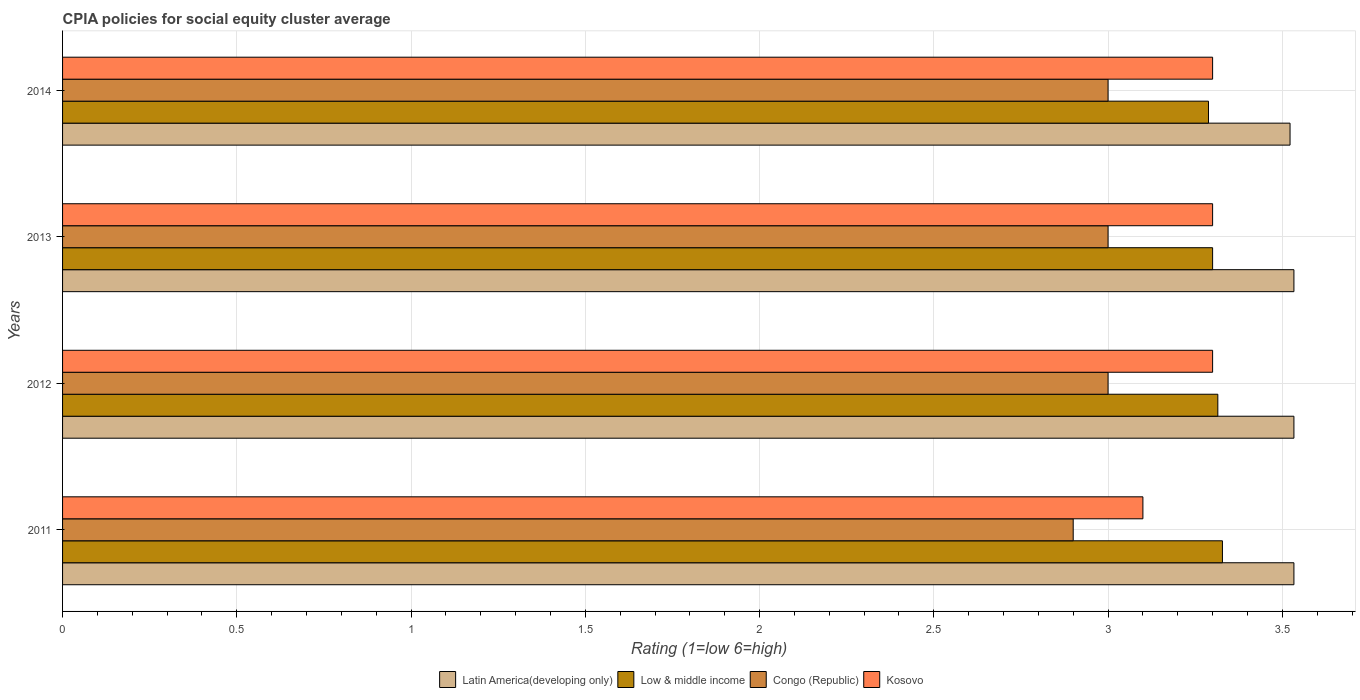How many different coloured bars are there?
Offer a terse response. 4. How many groups of bars are there?
Offer a terse response. 4. Are the number of bars on each tick of the Y-axis equal?
Your answer should be very brief. Yes. How many bars are there on the 3rd tick from the top?
Your answer should be compact. 4. How many bars are there on the 4th tick from the bottom?
Make the answer very short. 4. In how many cases, is the number of bars for a given year not equal to the number of legend labels?
Keep it short and to the point. 0. What is the CPIA rating in Latin America(developing only) in 2014?
Your answer should be very brief. 3.52. Across all years, what is the maximum CPIA rating in Congo (Republic)?
Give a very brief answer. 3. Across all years, what is the minimum CPIA rating in Latin America(developing only)?
Provide a succinct answer. 3.52. In which year was the CPIA rating in Kosovo maximum?
Your answer should be compact. 2012. What is the difference between the CPIA rating in Low & middle income in 2011 and that in 2014?
Make the answer very short. 0.04. What is the difference between the CPIA rating in Kosovo in 2013 and the CPIA rating in Low & middle income in 2012?
Provide a succinct answer. -0.02. What is the average CPIA rating in Congo (Republic) per year?
Your answer should be very brief. 2.98. In the year 2011, what is the difference between the CPIA rating in Congo (Republic) and CPIA rating in Low & middle income?
Keep it short and to the point. -0.43. In how many years, is the CPIA rating in Low & middle income greater than 1.6 ?
Make the answer very short. 4. What is the ratio of the CPIA rating in Low & middle income in 2011 to that in 2013?
Offer a terse response. 1.01. What is the difference between the highest and the second highest CPIA rating in Low & middle income?
Keep it short and to the point. 0.01. What is the difference between the highest and the lowest CPIA rating in Low & middle income?
Your answer should be compact. 0.04. What does the 4th bar from the top in 2013 represents?
Your response must be concise. Latin America(developing only). What does the 3rd bar from the bottom in 2014 represents?
Offer a very short reply. Congo (Republic). Is it the case that in every year, the sum of the CPIA rating in Latin America(developing only) and CPIA rating in Kosovo is greater than the CPIA rating in Low & middle income?
Offer a very short reply. Yes. Does the graph contain any zero values?
Ensure brevity in your answer.  No. What is the title of the graph?
Ensure brevity in your answer.  CPIA policies for social equity cluster average. Does "Euro area" appear as one of the legend labels in the graph?
Offer a very short reply. No. What is the label or title of the X-axis?
Offer a terse response. Rating (1=low 6=high). What is the label or title of the Y-axis?
Provide a short and direct response. Years. What is the Rating (1=low 6=high) of Latin America(developing only) in 2011?
Offer a very short reply. 3.53. What is the Rating (1=low 6=high) in Low & middle income in 2011?
Your answer should be compact. 3.33. What is the Rating (1=low 6=high) in Congo (Republic) in 2011?
Offer a very short reply. 2.9. What is the Rating (1=low 6=high) of Kosovo in 2011?
Your answer should be compact. 3.1. What is the Rating (1=low 6=high) of Latin America(developing only) in 2012?
Give a very brief answer. 3.53. What is the Rating (1=low 6=high) of Low & middle income in 2012?
Give a very brief answer. 3.31. What is the Rating (1=low 6=high) of Kosovo in 2012?
Keep it short and to the point. 3.3. What is the Rating (1=low 6=high) in Latin America(developing only) in 2013?
Offer a very short reply. 3.53. What is the Rating (1=low 6=high) of Low & middle income in 2013?
Make the answer very short. 3.3. What is the Rating (1=low 6=high) in Congo (Republic) in 2013?
Provide a short and direct response. 3. What is the Rating (1=low 6=high) of Latin America(developing only) in 2014?
Provide a succinct answer. 3.52. What is the Rating (1=low 6=high) in Low & middle income in 2014?
Your answer should be compact. 3.29. What is the Rating (1=low 6=high) of Kosovo in 2014?
Ensure brevity in your answer.  3.3. Across all years, what is the maximum Rating (1=low 6=high) in Latin America(developing only)?
Ensure brevity in your answer.  3.53. Across all years, what is the maximum Rating (1=low 6=high) of Low & middle income?
Provide a short and direct response. 3.33. Across all years, what is the maximum Rating (1=low 6=high) in Kosovo?
Your answer should be compact. 3.3. Across all years, what is the minimum Rating (1=low 6=high) in Latin America(developing only)?
Keep it short and to the point. 3.52. Across all years, what is the minimum Rating (1=low 6=high) in Low & middle income?
Offer a very short reply. 3.29. Across all years, what is the minimum Rating (1=low 6=high) of Kosovo?
Your response must be concise. 3.1. What is the total Rating (1=low 6=high) in Latin America(developing only) in the graph?
Ensure brevity in your answer.  14.12. What is the total Rating (1=low 6=high) in Low & middle income in the graph?
Offer a very short reply. 13.23. What is the total Rating (1=low 6=high) of Congo (Republic) in the graph?
Ensure brevity in your answer.  11.9. What is the difference between the Rating (1=low 6=high) in Low & middle income in 2011 and that in 2012?
Your answer should be very brief. 0.01. What is the difference between the Rating (1=low 6=high) in Congo (Republic) in 2011 and that in 2012?
Your answer should be very brief. -0.1. What is the difference between the Rating (1=low 6=high) in Low & middle income in 2011 and that in 2013?
Offer a terse response. 0.03. What is the difference between the Rating (1=low 6=high) of Kosovo in 2011 and that in 2013?
Provide a succinct answer. -0.2. What is the difference between the Rating (1=low 6=high) in Latin America(developing only) in 2011 and that in 2014?
Offer a very short reply. 0.01. What is the difference between the Rating (1=low 6=high) in Kosovo in 2011 and that in 2014?
Your response must be concise. -0.2. What is the difference between the Rating (1=low 6=high) of Low & middle income in 2012 and that in 2013?
Give a very brief answer. 0.01. What is the difference between the Rating (1=low 6=high) of Kosovo in 2012 and that in 2013?
Give a very brief answer. 0. What is the difference between the Rating (1=low 6=high) in Latin America(developing only) in 2012 and that in 2014?
Your answer should be very brief. 0.01. What is the difference between the Rating (1=low 6=high) in Low & middle income in 2012 and that in 2014?
Offer a terse response. 0.03. What is the difference between the Rating (1=low 6=high) of Latin America(developing only) in 2013 and that in 2014?
Give a very brief answer. 0.01. What is the difference between the Rating (1=low 6=high) in Low & middle income in 2013 and that in 2014?
Keep it short and to the point. 0.01. What is the difference between the Rating (1=low 6=high) of Congo (Republic) in 2013 and that in 2014?
Provide a short and direct response. 0. What is the difference between the Rating (1=low 6=high) of Kosovo in 2013 and that in 2014?
Keep it short and to the point. 0. What is the difference between the Rating (1=low 6=high) of Latin America(developing only) in 2011 and the Rating (1=low 6=high) of Low & middle income in 2012?
Provide a succinct answer. 0.22. What is the difference between the Rating (1=low 6=high) of Latin America(developing only) in 2011 and the Rating (1=low 6=high) of Congo (Republic) in 2012?
Your answer should be very brief. 0.53. What is the difference between the Rating (1=low 6=high) of Latin America(developing only) in 2011 and the Rating (1=low 6=high) of Kosovo in 2012?
Give a very brief answer. 0.23. What is the difference between the Rating (1=low 6=high) in Low & middle income in 2011 and the Rating (1=low 6=high) in Congo (Republic) in 2012?
Ensure brevity in your answer.  0.33. What is the difference between the Rating (1=low 6=high) in Low & middle income in 2011 and the Rating (1=low 6=high) in Kosovo in 2012?
Provide a succinct answer. 0.03. What is the difference between the Rating (1=low 6=high) in Congo (Republic) in 2011 and the Rating (1=low 6=high) in Kosovo in 2012?
Keep it short and to the point. -0.4. What is the difference between the Rating (1=low 6=high) in Latin America(developing only) in 2011 and the Rating (1=low 6=high) in Low & middle income in 2013?
Make the answer very short. 0.23. What is the difference between the Rating (1=low 6=high) of Latin America(developing only) in 2011 and the Rating (1=low 6=high) of Congo (Republic) in 2013?
Make the answer very short. 0.53. What is the difference between the Rating (1=low 6=high) in Latin America(developing only) in 2011 and the Rating (1=low 6=high) in Kosovo in 2013?
Keep it short and to the point. 0.23. What is the difference between the Rating (1=low 6=high) in Low & middle income in 2011 and the Rating (1=low 6=high) in Congo (Republic) in 2013?
Offer a terse response. 0.33. What is the difference between the Rating (1=low 6=high) of Low & middle income in 2011 and the Rating (1=low 6=high) of Kosovo in 2013?
Offer a terse response. 0.03. What is the difference between the Rating (1=low 6=high) of Latin America(developing only) in 2011 and the Rating (1=low 6=high) of Low & middle income in 2014?
Offer a terse response. 0.25. What is the difference between the Rating (1=low 6=high) of Latin America(developing only) in 2011 and the Rating (1=low 6=high) of Congo (Republic) in 2014?
Offer a very short reply. 0.53. What is the difference between the Rating (1=low 6=high) in Latin America(developing only) in 2011 and the Rating (1=low 6=high) in Kosovo in 2014?
Your answer should be very brief. 0.23. What is the difference between the Rating (1=low 6=high) in Low & middle income in 2011 and the Rating (1=low 6=high) in Congo (Republic) in 2014?
Make the answer very short. 0.33. What is the difference between the Rating (1=low 6=high) in Low & middle income in 2011 and the Rating (1=low 6=high) in Kosovo in 2014?
Ensure brevity in your answer.  0.03. What is the difference between the Rating (1=low 6=high) in Latin America(developing only) in 2012 and the Rating (1=low 6=high) in Low & middle income in 2013?
Your answer should be compact. 0.23. What is the difference between the Rating (1=low 6=high) of Latin America(developing only) in 2012 and the Rating (1=low 6=high) of Congo (Republic) in 2013?
Give a very brief answer. 0.53. What is the difference between the Rating (1=low 6=high) in Latin America(developing only) in 2012 and the Rating (1=low 6=high) in Kosovo in 2013?
Offer a very short reply. 0.23. What is the difference between the Rating (1=low 6=high) in Low & middle income in 2012 and the Rating (1=low 6=high) in Congo (Republic) in 2013?
Your answer should be compact. 0.32. What is the difference between the Rating (1=low 6=high) of Low & middle income in 2012 and the Rating (1=low 6=high) of Kosovo in 2013?
Provide a succinct answer. 0.01. What is the difference between the Rating (1=low 6=high) in Latin America(developing only) in 2012 and the Rating (1=low 6=high) in Low & middle income in 2014?
Offer a terse response. 0.25. What is the difference between the Rating (1=low 6=high) in Latin America(developing only) in 2012 and the Rating (1=low 6=high) in Congo (Republic) in 2014?
Give a very brief answer. 0.53. What is the difference between the Rating (1=low 6=high) in Latin America(developing only) in 2012 and the Rating (1=low 6=high) in Kosovo in 2014?
Make the answer very short. 0.23. What is the difference between the Rating (1=low 6=high) of Low & middle income in 2012 and the Rating (1=low 6=high) of Congo (Republic) in 2014?
Ensure brevity in your answer.  0.32. What is the difference between the Rating (1=low 6=high) in Low & middle income in 2012 and the Rating (1=low 6=high) in Kosovo in 2014?
Your response must be concise. 0.01. What is the difference between the Rating (1=low 6=high) in Congo (Republic) in 2012 and the Rating (1=low 6=high) in Kosovo in 2014?
Provide a short and direct response. -0.3. What is the difference between the Rating (1=low 6=high) in Latin America(developing only) in 2013 and the Rating (1=low 6=high) in Low & middle income in 2014?
Give a very brief answer. 0.25. What is the difference between the Rating (1=low 6=high) of Latin America(developing only) in 2013 and the Rating (1=low 6=high) of Congo (Republic) in 2014?
Provide a succinct answer. 0.53. What is the difference between the Rating (1=low 6=high) in Latin America(developing only) in 2013 and the Rating (1=low 6=high) in Kosovo in 2014?
Your answer should be compact. 0.23. What is the average Rating (1=low 6=high) of Latin America(developing only) per year?
Your response must be concise. 3.53. What is the average Rating (1=low 6=high) in Low & middle income per year?
Offer a very short reply. 3.31. What is the average Rating (1=low 6=high) in Congo (Republic) per year?
Your response must be concise. 2.98. What is the average Rating (1=low 6=high) in Kosovo per year?
Offer a terse response. 3.25. In the year 2011, what is the difference between the Rating (1=low 6=high) of Latin America(developing only) and Rating (1=low 6=high) of Low & middle income?
Make the answer very short. 0.21. In the year 2011, what is the difference between the Rating (1=low 6=high) of Latin America(developing only) and Rating (1=low 6=high) of Congo (Republic)?
Provide a short and direct response. 0.63. In the year 2011, what is the difference between the Rating (1=low 6=high) in Latin America(developing only) and Rating (1=low 6=high) in Kosovo?
Ensure brevity in your answer.  0.43. In the year 2011, what is the difference between the Rating (1=low 6=high) in Low & middle income and Rating (1=low 6=high) in Congo (Republic)?
Provide a succinct answer. 0.43. In the year 2011, what is the difference between the Rating (1=low 6=high) in Low & middle income and Rating (1=low 6=high) in Kosovo?
Keep it short and to the point. 0.23. In the year 2012, what is the difference between the Rating (1=low 6=high) of Latin America(developing only) and Rating (1=low 6=high) of Low & middle income?
Ensure brevity in your answer.  0.22. In the year 2012, what is the difference between the Rating (1=low 6=high) of Latin America(developing only) and Rating (1=low 6=high) of Congo (Republic)?
Provide a short and direct response. 0.53. In the year 2012, what is the difference between the Rating (1=low 6=high) of Latin America(developing only) and Rating (1=low 6=high) of Kosovo?
Your answer should be compact. 0.23. In the year 2012, what is the difference between the Rating (1=low 6=high) in Low & middle income and Rating (1=low 6=high) in Congo (Republic)?
Provide a short and direct response. 0.32. In the year 2012, what is the difference between the Rating (1=low 6=high) of Low & middle income and Rating (1=low 6=high) of Kosovo?
Your answer should be compact. 0.01. In the year 2012, what is the difference between the Rating (1=low 6=high) in Congo (Republic) and Rating (1=low 6=high) in Kosovo?
Keep it short and to the point. -0.3. In the year 2013, what is the difference between the Rating (1=low 6=high) of Latin America(developing only) and Rating (1=low 6=high) of Low & middle income?
Provide a succinct answer. 0.23. In the year 2013, what is the difference between the Rating (1=low 6=high) in Latin America(developing only) and Rating (1=low 6=high) in Congo (Republic)?
Offer a terse response. 0.53. In the year 2013, what is the difference between the Rating (1=low 6=high) in Latin America(developing only) and Rating (1=low 6=high) in Kosovo?
Offer a terse response. 0.23. In the year 2013, what is the difference between the Rating (1=low 6=high) of Low & middle income and Rating (1=low 6=high) of Congo (Republic)?
Provide a succinct answer. 0.3. In the year 2013, what is the difference between the Rating (1=low 6=high) of Low & middle income and Rating (1=low 6=high) of Kosovo?
Keep it short and to the point. 0. In the year 2014, what is the difference between the Rating (1=low 6=high) of Latin America(developing only) and Rating (1=low 6=high) of Low & middle income?
Your response must be concise. 0.23. In the year 2014, what is the difference between the Rating (1=low 6=high) in Latin America(developing only) and Rating (1=low 6=high) in Congo (Republic)?
Ensure brevity in your answer.  0.52. In the year 2014, what is the difference between the Rating (1=low 6=high) in Latin America(developing only) and Rating (1=low 6=high) in Kosovo?
Make the answer very short. 0.22. In the year 2014, what is the difference between the Rating (1=low 6=high) of Low & middle income and Rating (1=low 6=high) of Congo (Republic)?
Your response must be concise. 0.29. In the year 2014, what is the difference between the Rating (1=low 6=high) of Low & middle income and Rating (1=low 6=high) of Kosovo?
Ensure brevity in your answer.  -0.01. In the year 2014, what is the difference between the Rating (1=low 6=high) in Congo (Republic) and Rating (1=low 6=high) in Kosovo?
Offer a very short reply. -0.3. What is the ratio of the Rating (1=low 6=high) of Low & middle income in 2011 to that in 2012?
Make the answer very short. 1. What is the ratio of the Rating (1=low 6=high) in Congo (Republic) in 2011 to that in 2012?
Provide a succinct answer. 0.97. What is the ratio of the Rating (1=low 6=high) of Kosovo in 2011 to that in 2012?
Provide a succinct answer. 0.94. What is the ratio of the Rating (1=low 6=high) of Latin America(developing only) in 2011 to that in 2013?
Your answer should be very brief. 1. What is the ratio of the Rating (1=low 6=high) of Low & middle income in 2011 to that in 2013?
Offer a very short reply. 1.01. What is the ratio of the Rating (1=low 6=high) of Congo (Republic) in 2011 to that in 2013?
Your answer should be very brief. 0.97. What is the ratio of the Rating (1=low 6=high) in Kosovo in 2011 to that in 2013?
Offer a very short reply. 0.94. What is the ratio of the Rating (1=low 6=high) of Low & middle income in 2011 to that in 2014?
Your response must be concise. 1.01. What is the ratio of the Rating (1=low 6=high) of Congo (Republic) in 2011 to that in 2014?
Your answer should be very brief. 0.97. What is the ratio of the Rating (1=low 6=high) in Kosovo in 2011 to that in 2014?
Offer a terse response. 0.94. What is the ratio of the Rating (1=low 6=high) of Latin America(developing only) in 2012 to that in 2013?
Ensure brevity in your answer.  1. What is the ratio of the Rating (1=low 6=high) of Congo (Republic) in 2012 to that in 2013?
Make the answer very short. 1. What is the ratio of the Rating (1=low 6=high) of Low & middle income in 2012 to that in 2014?
Keep it short and to the point. 1.01. What is the ratio of the Rating (1=low 6=high) of Kosovo in 2012 to that in 2014?
Keep it short and to the point. 1. What is the ratio of the Rating (1=low 6=high) of Latin America(developing only) in 2013 to that in 2014?
Your response must be concise. 1. What is the ratio of the Rating (1=low 6=high) of Congo (Republic) in 2013 to that in 2014?
Offer a terse response. 1. What is the difference between the highest and the second highest Rating (1=low 6=high) of Latin America(developing only)?
Offer a very short reply. 0. What is the difference between the highest and the second highest Rating (1=low 6=high) of Low & middle income?
Make the answer very short. 0.01. What is the difference between the highest and the second highest Rating (1=low 6=high) of Congo (Republic)?
Your response must be concise. 0. What is the difference between the highest and the second highest Rating (1=low 6=high) of Kosovo?
Your answer should be compact. 0. What is the difference between the highest and the lowest Rating (1=low 6=high) of Latin America(developing only)?
Provide a succinct answer. 0.01. What is the difference between the highest and the lowest Rating (1=low 6=high) in Low & middle income?
Offer a terse response. 0.04. What is the difference between the highest and the lowest Rating (1=low 6=high) in Kosovo?
Offer a terse response. 0.2. 